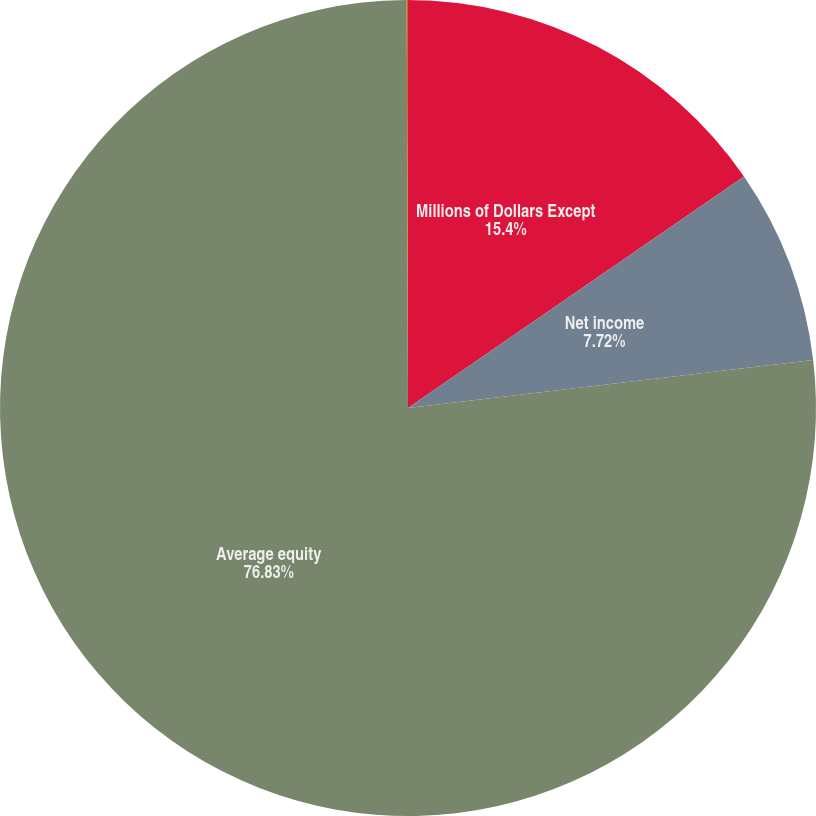Convert chart to OTSL. <chart><loc_0><loc_0><loc_500><loc_500><pie_chart><fcel>Millions of Dollars Except<fcel>Net income<fcel>Average equity<fcel>Return on average common<nl><fcel>15.4%<fcel>7.72%<fcel>76.83%<fcel>0.05%<nl></chart> 